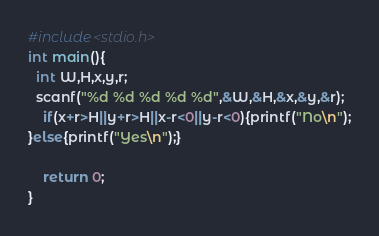Convert code to text. <code><loc_0><loc_0><loc_500><loc_500><_C_>#include<stdio.h>
int main(){
  int W,H,x,y,r;
  scanf("%d %d %d %d %d",&W,&H,&x,&y,&r);
    if(x+r>H||y+r>H||x-r<0||y-r<0){printf("No\n");
}else{printf("Yes\n");}

    return 0;
}</code> 